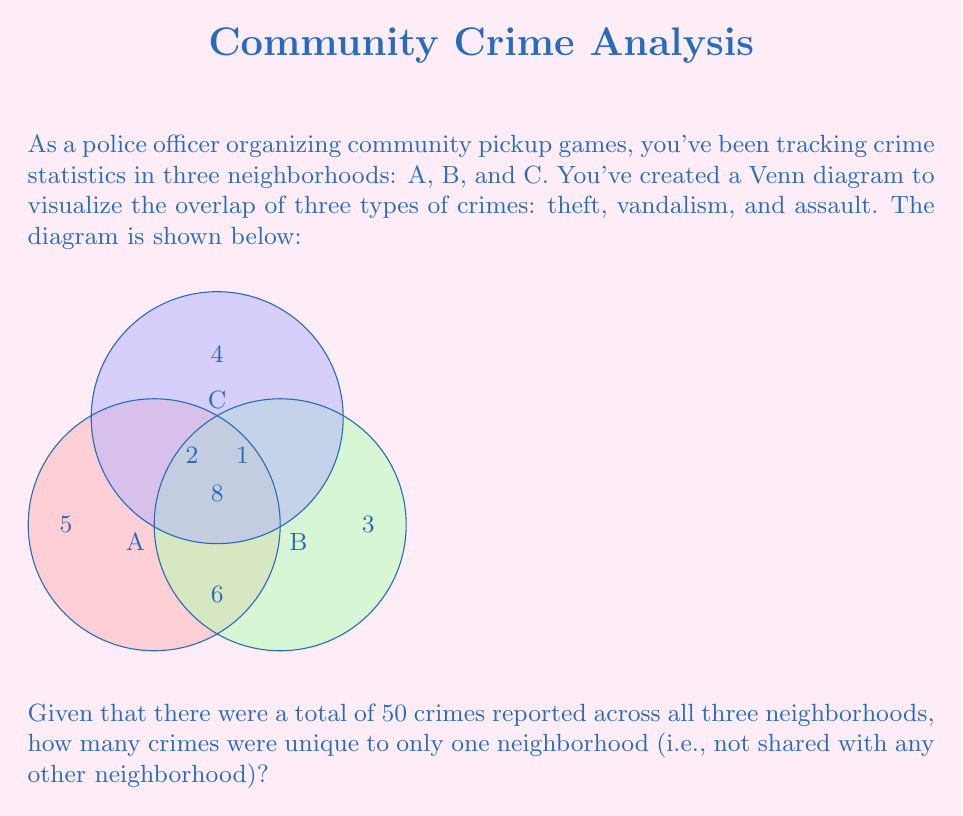What is the answer to this math problem? Let's approach this step-by-step using set theory:

1) Let's define our sets:
   A: crimes in neighborhood A
   B: crimes in neighborhood B
   C: crimes in neighborhood C

2) From the Venn diagram, we can identify:
   $|A \cap B \cap C| = 8$ (center)
   $|A \cap B| - |A \cap B \cap C| = 6$ (bottom)
   $|B \cap C| - |A \cap B \cap C| = 1$ (right)
   $|A \cap C| - |A \cap B \cap C| = 2$ (left)
   Unique to A: 5
   Unique to B: 3
   Unique to C: 4

3) Let's calculate the total crimes shown in the Venn diagram:
   $8 + 6 + 1 + 2 + 5 + 3 + 4 = 29$

4) We're told there were 50 crimes in total. So the number of crimes not represented in the overlapping areas is:
   $50 - 29 = 21$

5) These 21 crimes are the ones unique to only one neighborhood.

6) Adding this to the unique crimes we can see in the Venn diagram:
   Unique crimes = $21 + 5 + 3 + 4 = 33$

Therefore, 33 crimes were unique to only one neighborhood.
Answer: 33 